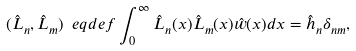<formula> <loc_0><loc_0><loc_500><loc_500>( \hat { L } _ { n } , \hat { L } _ { m } ) \ e q d e f \int _ { 0 } ^ { \infty } \hat { L } _ { n } ( x ) \hat { L } _ { m } ( x ) \hat { w } ( x ) d x = \hat { h } _ { n } \delta _ { n m } ,</formula> 